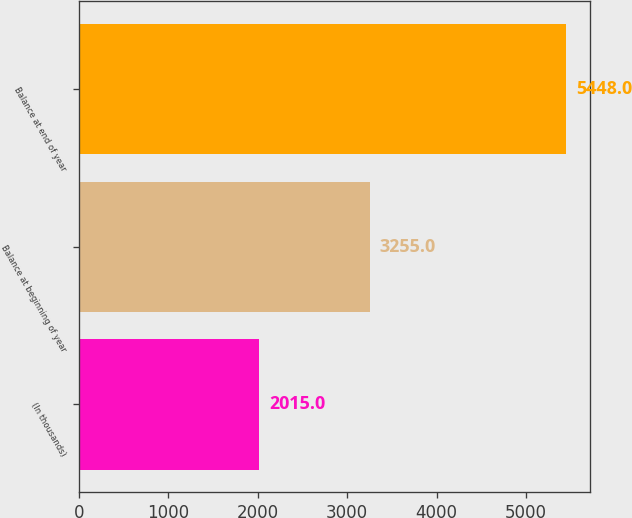Convert chart to OTSL. <chart><loc_0><loc_0><loc_500><loc_500><bar_chart><fcel>(In thousands)<fcel>Balance at beginning of year<fcel>Balance at end of year<nl><fcel>2015<fcel>3255<fcel>5448<nl></chart> 